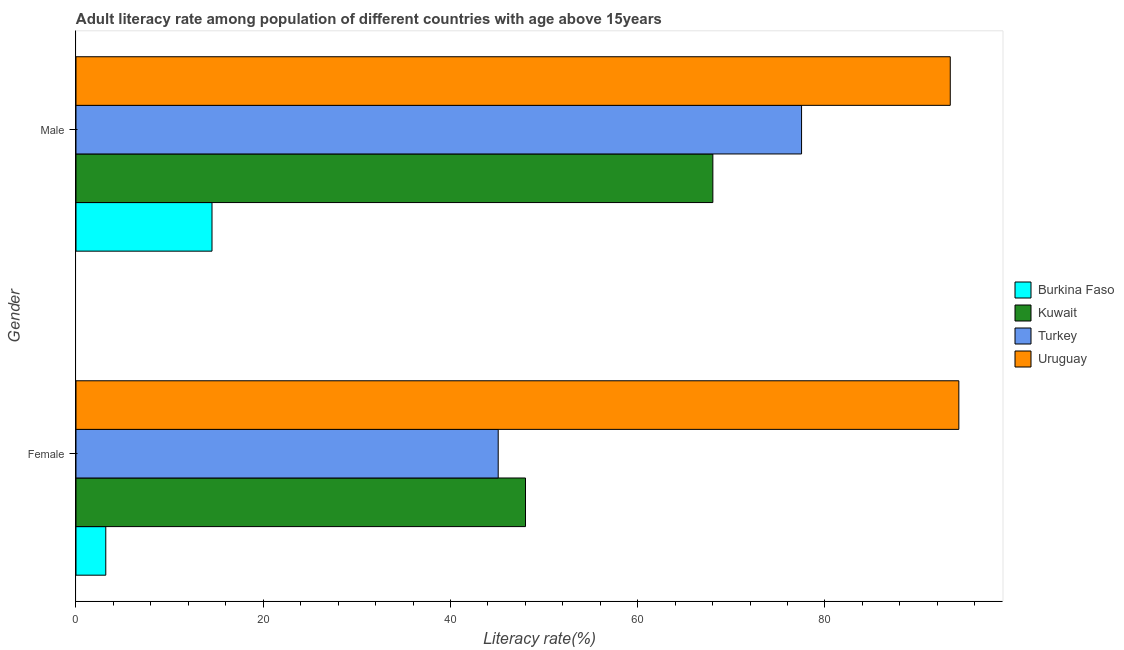How many different coloured bars are there?
Offer a terse response. 4. How many bars are there on the 2nd tick from the top?
Your response must be concise. 4. What is the female adult literacy rate in Kuwait?
Your answer should be very brief. 48.02. Across all countries, what is the maximum female adult literacy rate?
Your answer should be compact. 94.3. Across all countries, what is the minimum male adult literacy rate?
Offer a terse response. 14.53. In which country was the female adult literacy rate maximum?
Your response must be concise. Uruguay. In which country was the male adult literacy rate minimum?
Provide a succinct answer. Burkina Faso. What is the total female adult literacy rate in the graph?
Make the answer very short. 190.6. What is the difference between the male adult literacy rate in Kuwait and that in Turkey?
Your answer should be compact. -9.48. What is the difference between the male adult literacy rate in Turkey and the female adult literacy rate in Kuwait?
Your answer should be compact. 29.49. What is the average male adult literacy rate per country?
Give a very brief answer. 63.36. What is the difference between the male adult literacy rate and female adult literacy rate in Uruguay?
Offer a terse response. -0.92. What is the ratio of the male adult literacy rate in Burkina Faso to that in Uruguay?
Your answer should be very brief. 0.16. Is the male adult literacy rate in Kuwait less than that in Turkey?
Make the answer very short. Yes. What does the 1st bar from the top in Male represents?
Offer a very short reply. Uruguay. What does the 2nd bar from the bottom in Male represents?
Your answer should be very brief. Kuwait. How many bars are there?
Give a very brief answer. 8. Are the values on the major ticks of X-axis written in scientific E-notation?
Give a very brief answer. No. Does the graph contain grids?
Make the answer very short. No. Where does the legend appear in the graph?
Give a very brief answer. Center right. How many legend labels are there?
Your response must be concise. 4. How are the legend labels stacked?
Make the answer very short. Vertical. What is the title of the graph?
Make the answer very short. Adult literacy rate among population of different countries with age above 15years. What is the label or title of the X-axis?
Your answer should be very brief. Literacy rate(%). What is the Literacy rate(%) in Burkina Faso in Female?
Keep it short and to the point. 3.18. What is the Literacy rate(%) in Kuwait in Female?
Your answer should be compact. 48.02. What is the Literacy rate(%) of Turkey in Female?
Give a very brief answer. 45.1. What is the Literacy rate(%) of Uruguay in Female?
Make the answer very short. 94.3. What is the Literacy rate(%) in Burkina Faso in Male?
Offer a very short reply. 14.53. What is the Literacy rate(%) of Kuwait in Male?
Offer a terse response. 68.03. What is the Literacy rate(%) of Turkey in Male?
Make the answer very short. 77.5. What is the Literacy rate(%) of Uruguay in Male?
Provide a short and direct response. 93.39. Across all Gender, what is the maximum Literacy rate(%) of Burkina Faso?
Your answer should be very brief. 14.53. Across all Gender, what is the maximum Literacy rate(%) of Kuwait?
Provide a short and direct response. 68.03. Across all Gender, what is the maximum Literacy rate(%) of Turkey?
Keep it short and to the point. 77.5. Across all Gender, what is the maximum Literacy rate(%) of Uruguay?
Provide a short and direct response. 94.3. Across all Gender, what is the minimum Literacy rate(%) in Burkina Faso?
Provide a succinct answer. 3.18. Across all Gender, what is the minimum Literacy rate(%) of Kuwait?
Ensure brevity in your answer.  48.02. Across all Gender, what is the minimum Literacy rate(%) of Turkey?
Give a very brief answer. 45.1. Across all Gender, what is the minimum Literacy rate(%) in Uruguay?
Give a very brief answer. 93.39. What is the total Literacy rate(%) of Burkina Faso in the graph?
Provide a succinct answer. 17.71. What is the total Literacy rate(%) of Kuwait in the graph?
Keep it short and to the point. 116.04. What is the total Literacy rate(%) of Turkey in the graph?
Your answer should be compact. 122.6. What is the total Literacy rate(%) in Uruguay in the graph?
Keep it short and to the point. 187.69. What is the difference between the Literacy rate(%) of Burkina Faso in Female and that in Male?
Provide a succinct answer. -11.35. What is the difference between the Literacy rate(%) in Kuwait in Female and that in Male?
Your answer should be compact. -20.01. What is the difference between the Literacy rate(%) in Turkey in Female and that in Male?
Your answer should be compact. -32.41. What is the difference between the Literacy rate(%) of Uruguay in Female and that in Male?
Provide a short and direct response. 0.92. What is the difference between the Literacy rate(%) of Burkina Faso in Female and the Literacy rate(%) of Kuwait in Male?
Provide a succinct answer. -64.85. What is the difference between the Literacy rate(%) in Burkina Faso in Female and the Literacy rate(%) in Turkey in Male?
Offer a terse response. -74.32. What is the difference between the Literacy rate(%) in Burkina Faso in Female and the Literacy rate(%) in Uruguay in Male?
Give a very brief answer. -90.21. What is the difference between the Literacy rate(%) of Kuwait in Female and the Literacy rate(%) of Turkey in Male?
Give a very brief answer. -29.49. What is the difference between the Literacy rate(%) in Kuwait in Female and the Literacy rate(%) in Uruguay in Male?
Your answer should be compact. -45.37. What is the difference between the Literacy rate(%) in Turkey in Female and the Literacy rate(%) in Uruguay in Male?
Provide a succinct answer. -48.29. What is the average Literacy rate(%) of Burkina Faso per Gender?
Keep it short and to the point. 8.86. What is the average Literacy rate(%) in Kuwait per Gender?
Give a very brief answer. 58.02. What is the average Literacy rate(%) in Turkey per Gender?
Your answer should be very brief. 61.3. What is the average Literacy rate(%) in Uruguay per Gender?
Make the answer very short. 93.85. What is the difference between the Literacy rate(%) of Burkina Faso and Literacy rate(%) of Kuwait in Female?
Provide a succinct answer. -44.83. What is the difference between the Literacy rate(%) of Burkina Faso and Literacy rate(%) of Turkey in Female?
Your answer should be very brief. -41.92. What is the difference between the Literacy rate(%) in Burkina Faso and Literacy rate(%) in Uruguay in Female?
Ensure brevity in your answer.  -91.12. What is the difference between the Literacy rate(%) of Kuwait and Literacy rate(%) of Turkey in Female?
Offer a very short reply. 2.92. What is the difference between the Literacy rate(%) of Kuwait and Literacy rate(%) of Uruguay in Female?
Your response must be concise. -46.29. What is the difference between the Literacy rate(%) of Turkey and Literacy rate(%) of Uruguay in Female?
Provide a short and direct response. -49.21. What is the difference between the Literacy rate(%) in Burkina Faso and Literacy rate(%) in Kuwait in Male?
Keep it short and to the point. -53.5. What is the difference between the Literacy rate(%) of Burkina Faso and Literacy rate(%) of Turkey in Male?
Offer a terse response. -62.98. What is the difference between the Literacy rate(%) in Burkina Faso and Literacy rate(%) in Uruguay in Male?
Your response must be concise. -78.86. What is the difference between the Literacy rate(%) of Kuwait and Literacy rate(%) of Turkey in Male?
Provide a short and direct response. -9.48. What is the difference between the Literacy rate(%) of Kuwait and Literacy rate(%) of Uruguay in Male?
Your response must be concise. -25.36. What is the difference between the Literacy rate(%) in Turkey and Literacy rate(%) in Uruguay in Male?
Provide a short and direct response. -15.88. What is the ratio of the Literacy rate(%) of Burkina Faso in Female to that in Male?
Offer a very short reply. 0.22. What is the ratio of the Literacy rate(%) of Kuwait in Female to that in Male?
Keep it short and to the point. 0.71. What is the ratio of the Literacy rate(%) of Turkey in Female to that in Male?
Provide a succinct answer. 0.58. What is the ratio of the Literacy rate(%) of Uruguay in Female to that in Male?
Offer a very short reply. 1.01. What is the difference between the highest and the second highest Literacy rate(%) of Burkina Faso?
Provide a short and direct response. 11.35. What is the difference between the highest and the second highest Literacy rate(%) of Kuwait?
Your answer should be compact. 20.01. What is the difference between the highest and the second highest Literacy rate(%) of Turkey?
Offer a terse response. 32.41. What is the difference between the highest and the second highest Literacy rate(%) of Uruguay?
Ensure brevity in your answer.  0.92. What is the difference between the highest and the lowest Literacy rate(%) of Burkina Faso?
Your answer should be very brief. 11.35. What is the difference between the highest and the lowest Literacy rate(%) of Kuwait?
Your response must be concise. 20.01. What is the difference between the highest and the lowest Literacy rate(%) of Turkey?
Offer a very short reply. 32.41. What is the difference between the highest and the lowest Literacy rate(%) of Uruguay?
Provide a succinct answer. 0.92. 